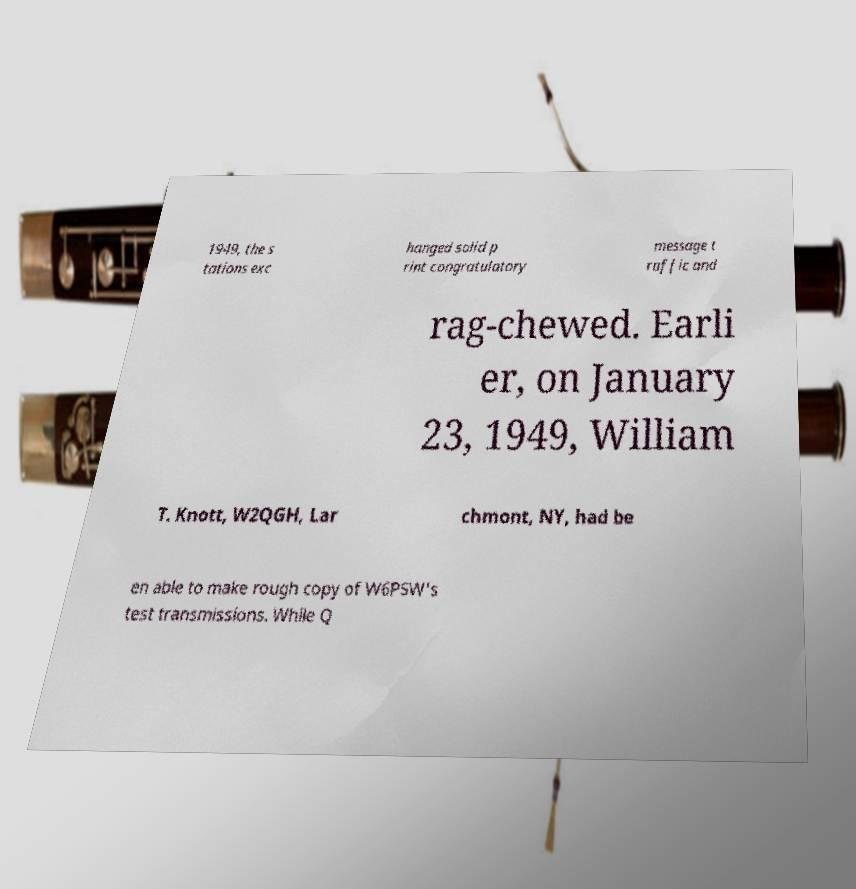There's text embedded in this image that I need extracted. Can you transcribe it verbatim? 1949, the s tations exc hanged solid p rint congratulatory message t raffic and rag-chewed. Earli er, on January 23, 1949, William T. Knott, W2QGH, Lar chmont, NY, had be en able to make rough copy of W6PSW's test transmissions. While Q 